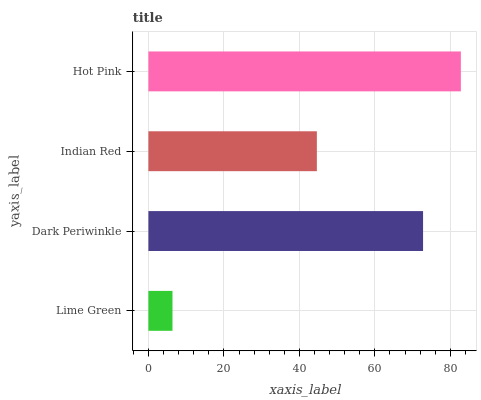Is Lime Green the minimum?
Answer yes or no. Yes. Is Hot Pink the maximum?
Answer yes or no. Yes. Is Dark Periwinkle the minimum?
Answer yes or no. No. Is Dark Periwinkle the maximum?
Answer yes or no. No. Is Dark Periwinkle greater than Lime Green?
Answer yes or no. Yes. Is Lime Green less than Dark Periwinkle?
Answer yes or no. Yes. Is Lime Green greater than Dark Periwinkle?
Answer yes or no. No. Is Dark Periwinkle less than Lime Green?
Answer yes or no. No. Is Dark Periwinkle the high median?
Answer yes or no. Yes. Is Indian Red the low median?
Answer yes or no. Yes. Is Indian Red the high median?
Answer yes or no. No. Is Hot Pink the low median?
Answer yes or no. No. 